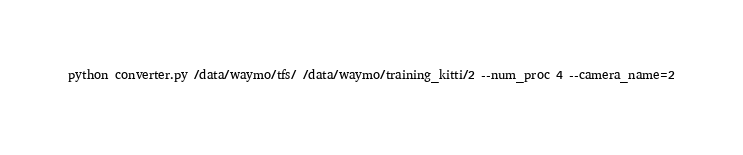Convert code to text. <code><loc_0><loc_0><loc_500><loc_500><_Bash_>python converter.py /data/waymo/tfs/ /data/waymo/training_kitti/2 --num_proc 4 --camera_name=2</code> 